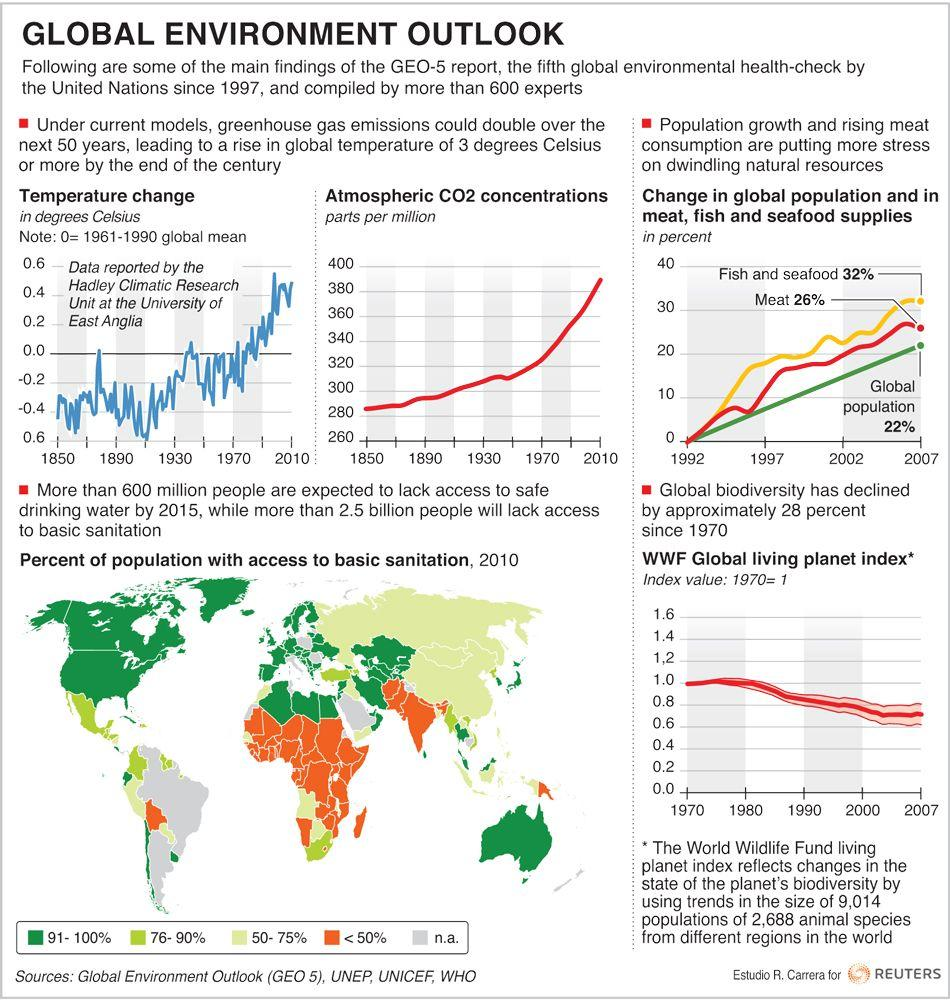Outline some significant characteristics in this image. The atmospheric CO2 concentration for the year 2010 was 390 parts per million. According to a study conducted in 2010, over 90% of the population in the United States had access to basic sanitation facilities. The atmospheric CO2 concentration for the year 1910 was 300 parts per million. The change in meat supplies in 2002 was 20%. In 2010, it was estimated that less than half of the population in India had access to basic sanitation. 